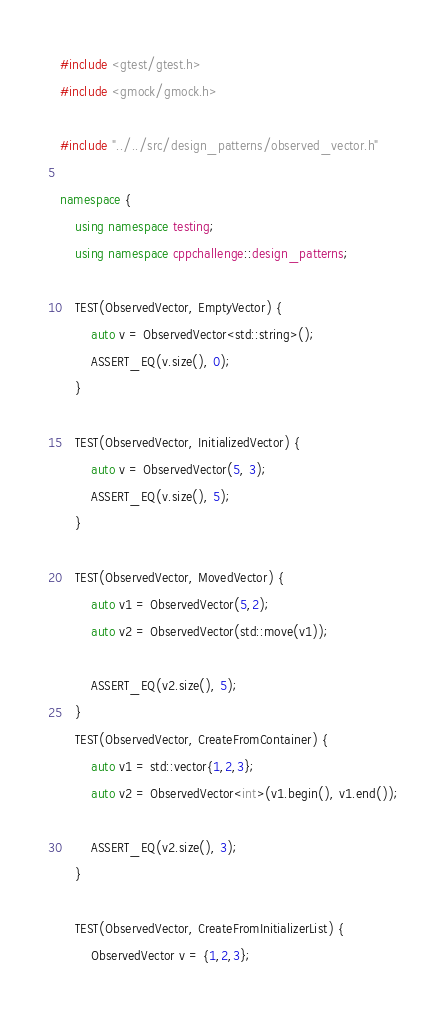<code> <loc_0><loc_0><loc_500><loc_500><_C++_>#include <gtest/gtest.h>
#include <gmock/gmock.h>

#include "../../src/design_patterns/observed_vector.h"

namespace {
    using namespace testing;
    using namespace cppchallenge::design_patterns;

    TEST(ObservedVector, EmptyVector) {
        auto v = ObservedVector<std::string>();
        ASSERT_EQ(v.size(), 0);
    }

    TEST(ObservedVector, InitializedVector) {
        auto v = ObservedVector(5, 3);
        ASSERT_EQ(v.size(), 5);
    }

    TEST(ObservedVector, MovedVector) {
        auto v1 = ObservedVector(5,2);
        auto v2 = ObservedVector(std::move(v1));

        ASSERT_EQ(v2.size(), 5);
    }
    TEST(ObservedVector, CreateFromContainer) {
        auto v1 = std::vector{1,2,3};
        auto v2 = ObservedVector<int>(v1.begin(), v1.end());

        ASSERT_EQ(v2.size(), 3);
    }

    TEST(ObservedVector, CreateFromInitializerList) {
        ObservedVector v = {1,2,3};
</code> 